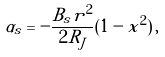Convert formula to latex. <formula><loc_0><loc_0><loc_500><loc_500>\alpha _ { s } = - \frac { B _ { s } r ^ { 2 } } { 2 R _ { J } } ( 1 - x ^ { 2 } ) \, ,</formula> 